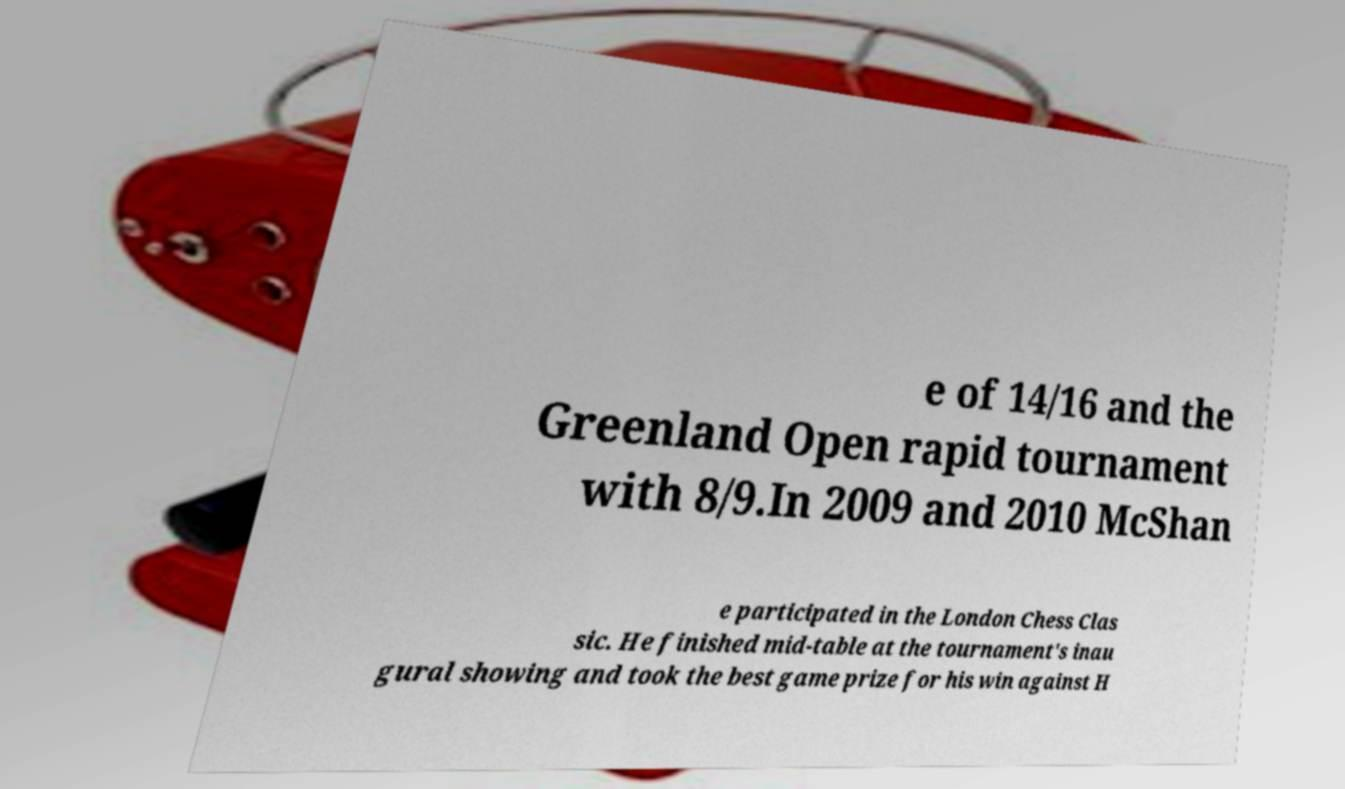Could you assist in decoding the text presented in this image and type it out clearly? e of 14/16 and the Greenland Open rapid tournament with 8/9.In 2009 and 2010 McShan e participated in the London Chess Clas sic. He finished mid-table at the tournament's inau gural showing and took the best game prize for his win against H 